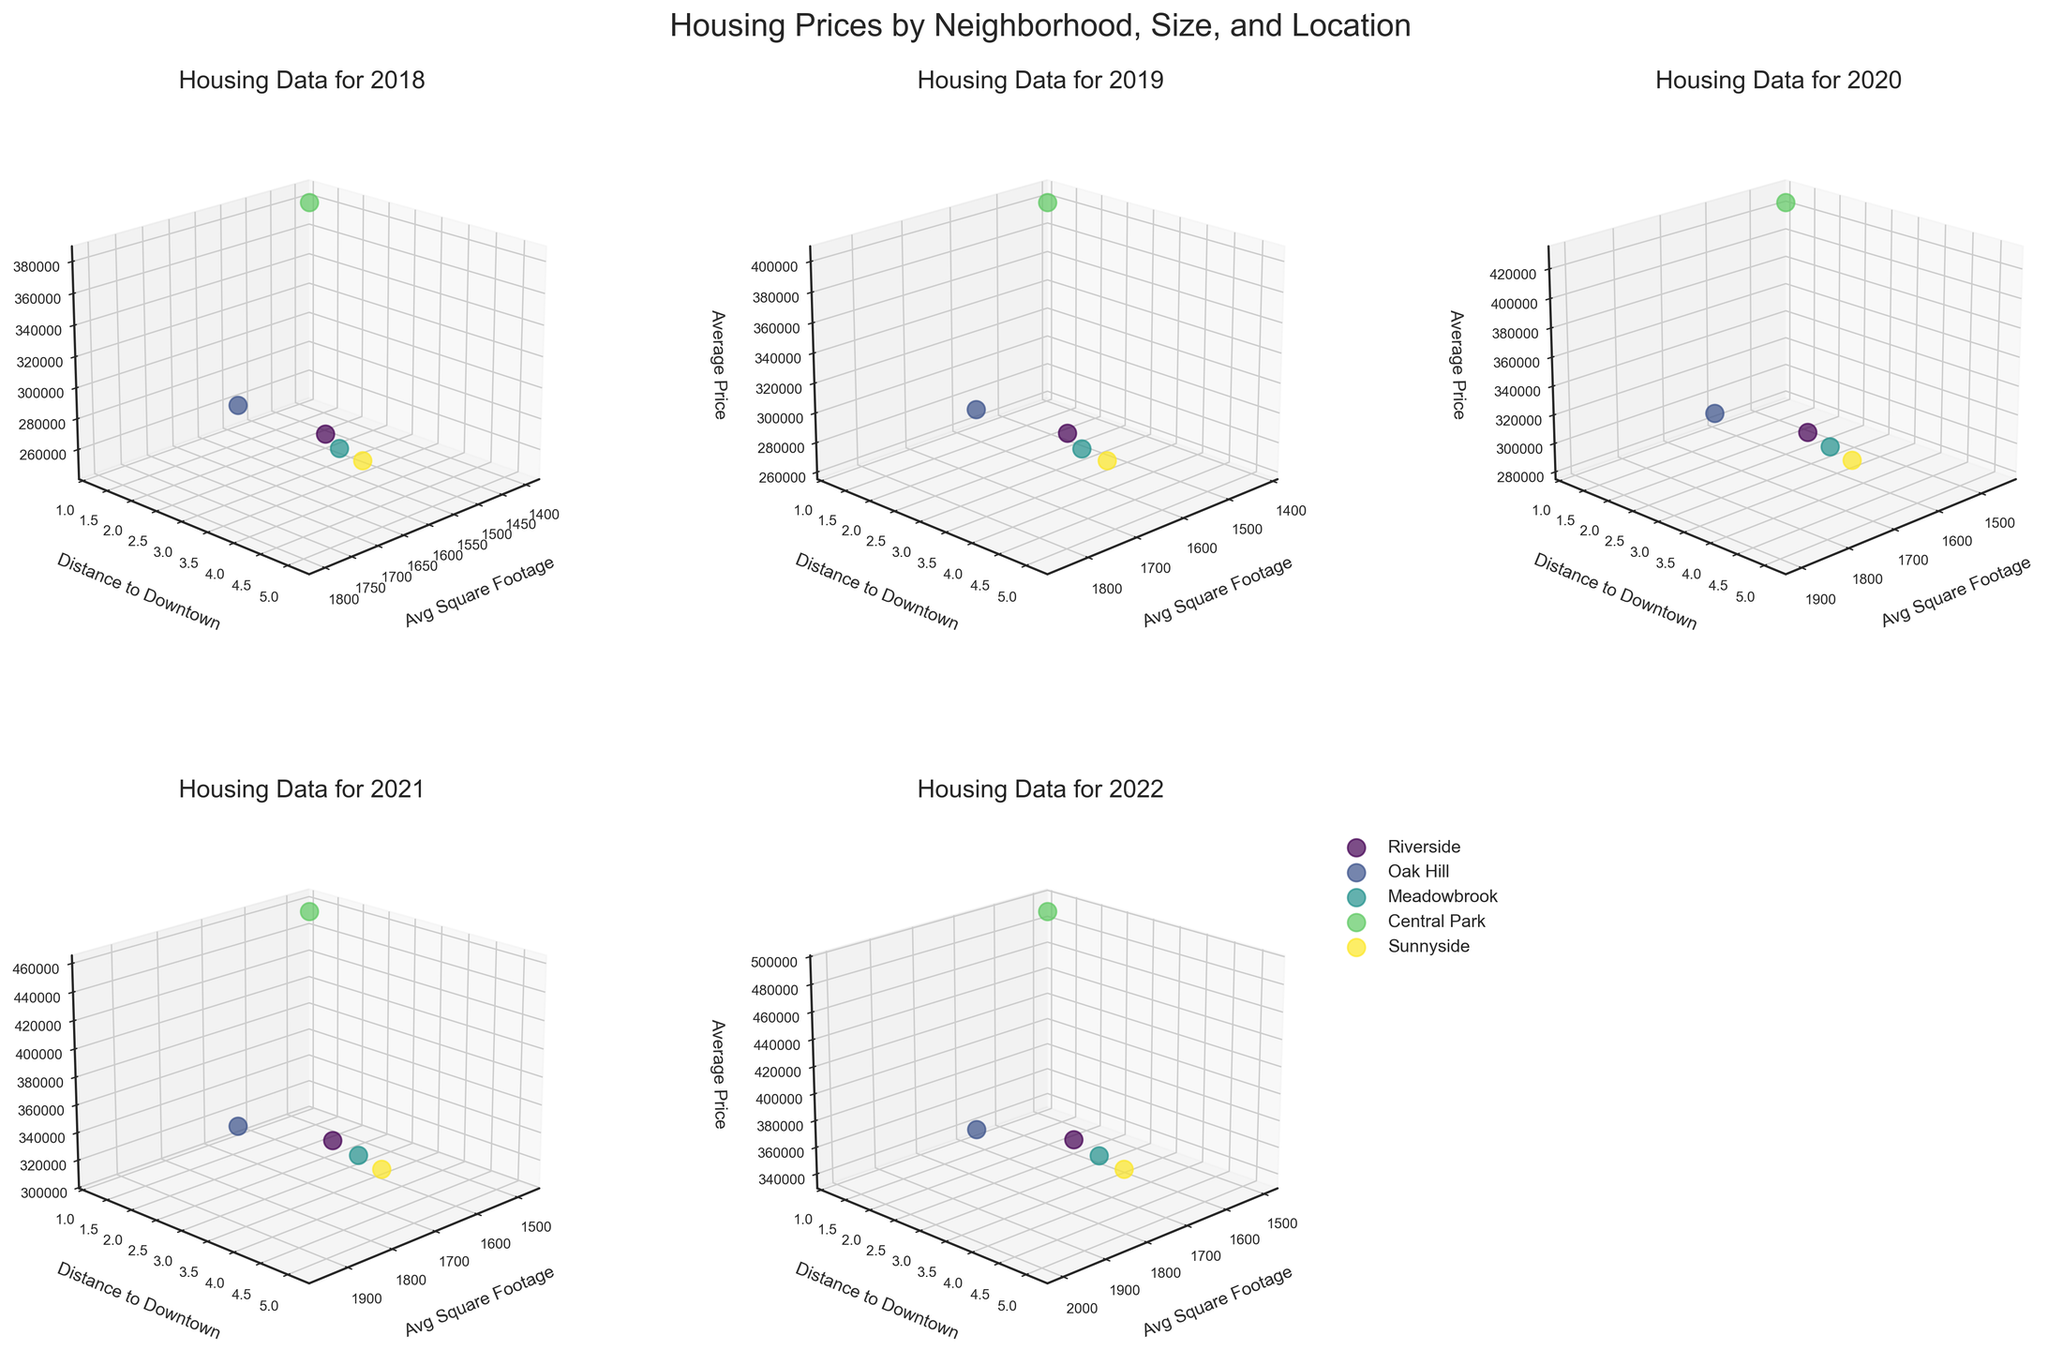Which neighborhood has the highest average price in 2022? The subplot for 2022 shows that Central Park has the highest average price. It is evident because the data point for Central Park is positioned highest on the Average Price axis in that year.
Answer: Central Park What is the trend of average prices in Riverside from 2018 to 2022? Observing the plots for each year, we can see that the average price in Riverside increases steadily from $250,000 in 2018 to $340,000 in 2022. This indicates a rising trend in average prices in Riverside over these years.
Answer: Increasing Which neighborhood has the smallest square footage on average, and in which year? Checking all the subplots, Central Park consistently shows the smallest average square footage across all years, with values around 1400 to 1500 square feet.
Answer: Central Park (2018-2022) In 2019, how much did the average price for Oak Hill increase compared to 2018? In the 2018 subplot, the average price for Oak Hill is $320,000. In the 2019 subplot, it is $335,000. The difference is $335,000 - $320,000 = $15,000.
Answer: $15,000 How does the distance to downtown correlate with average prices in 2020? In the 2020 subplot, the neighborhoods closer to downtown (like Central Park) have higher average prices, while those farther away (like Sunnyside) have lower prices. This indicates a negative correlation between distance to downtown and average prices.
Answer: Negative correlation Which year shows the highest overall average price for all neighborhoods combined? By comparing the average prices across all subplots, 2022 appears to have the highest overall average prices, with most neighborhoods showing a peak compared to previous years.
Answer: 2022 From 2018 to 2022, which neighborhood has shown the most significant increase in average price? By comparing the starting and ending average prices for each neighborhood over the years, Central Park shows the most significant jump, going from $380,000 in 2018 to $490,000 in 2022, an increase of $110,000.
Answer: Central Park Which neighborhood in 2021 has both high average price and large square footage? In the 2021 subplot, Oak Hill stands out with both a high average price of $380,000 and a large square footage of 1950.
Answer: Oak Hill 